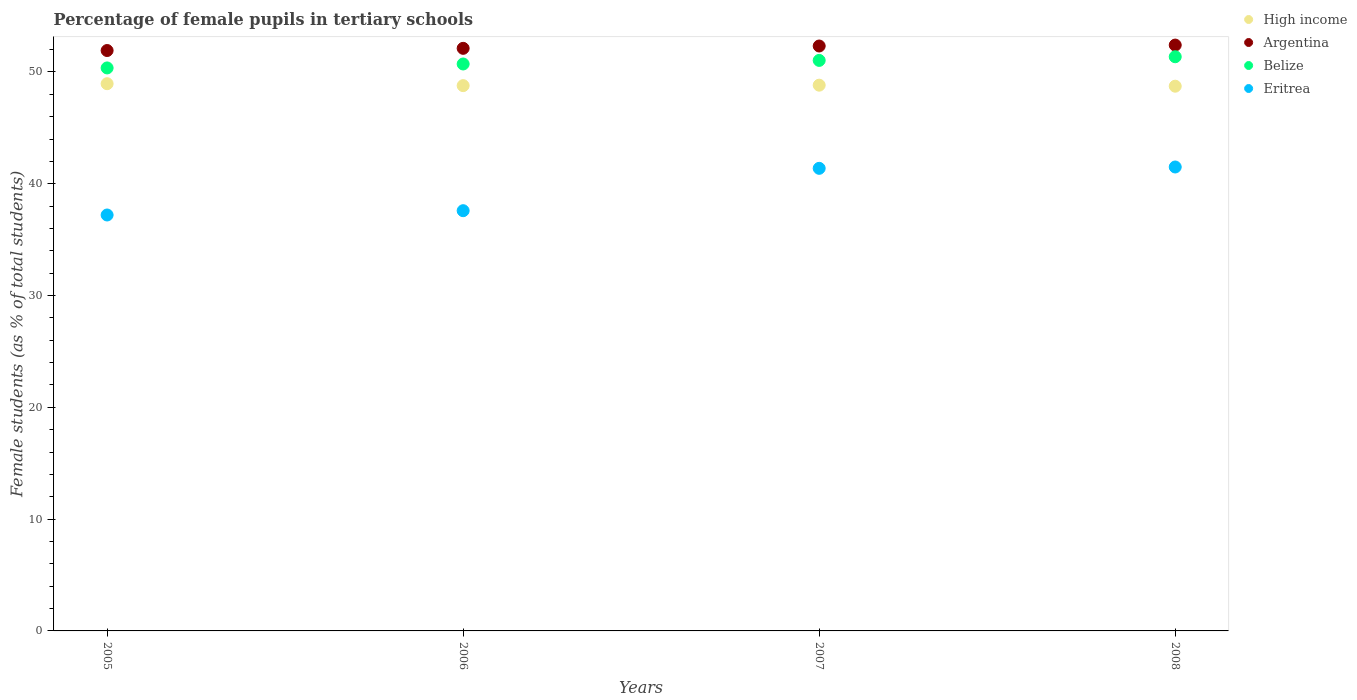How many different coloured dotlines are there?
Provide a short and direct response. 4. What is the percentage of female pupils in tertiary schools in Belize in 2007?
Give a very brief answer. 51.03. Across all years, what is the maximum percentage of female pupils in tertiary schools in High income?
Make the answer very short. 48.95. Across all years, what is the minimum percentage of female pupils in tertiary schools in Eritrea?
Give a very brief answer. 37.2. In which year was the percentage of female pupils in tertiary schools in Argentina maximum?
Ensure brevity in your answer.  2008. What is the total percentage of female pupils in tertiary schools in Eritrea in the graph?
Keep it short and to the point. 157.67. What is the difference between the percentage of female pupils in tertiary schools in Belize in 2005 and that in 2008?
Make the answer very short. -1. What is the difference between the percentage of female pupils in tertiary schools in Eritrea in 2007 and the percentage of female pupils in tertiary schools in High income in 2008?
Your answer should be very brief. -7.35. What is the average percentage of female pupils in tertiary schools in Eritrea per year?
Your answer should be very brief. 39.42. In the year 2007, what is the difference between the percentage of female pupils in tertiary schools in High income and percentage of female pupils in tertiary schools in Eritrea?
Offer a very short reply. 7.44. In how many years, is the percentage of female pupils in tertiary schools in Eritrea greater than 38 %?
Provide a succinct answer. 2. What is the ratio of the percentage of female pupils in tertiary schools in High income in 2005 to that in 2008?
Ensure brevity in your answer.  1. Is the percentage of female pupils in tertiary schools in Argentina in 2007 less than that in 2008?
Your answer should be very brief. Yes. What is the difference between the highest and the second highest percentage of female pupils in tertiary schools in Belize?
Keep it short and to the point. 0.33. What is the difference between the highest and the lowest percentage of female pupils in tertiary schools in Argentina?
Ensure brevity in your answer.  0.49. In how many years, is the percentage of female pupils in tertiary schools in Eritrea greater than the average percentage of female pupils in tertiary schools in Eritrea taken over all years?
Your answer should be very brief. 2. Is it the case that in every year, the sum of the percentage of female pupils in tertiary schools in Argentina and percentage of female pupils in tertiary schools in High income  is greater than the sum of percentage of female pupils in tertiary schools in Belize and percentage of female pupils in tertiary schools in Eritrea?
Give a very brief answer. Yes. Does the percentage of female pupils in tertiary schools in Belize monotonically increase over the years?
Make the answer very short. Yes. Is the percentage of female pupils in tertiary schools in Eritrea strictly greater than the percentage of female pupils in tertiary schools in Belize over the years?
Your answer should be very brief. No. How many years are there in the graph?
Offer a very short reply. 4. Are the values on the major ticks of Y-axis written in scientific E-notation?
Offer a very short reply. No. Where does the legend appear in the graph?
Keep it short and to the point. Top right. How many legend labels are there?
Give a very brief answer. 4. How are the legend labels stacked?
Your answer should be compact. Vertical. What is the title of the graph?
Keep it short and to the point. Percentage of female pupils in tertiary schools. Does "Croatia" appear as one of the legend labels in the graph?
Offer a very short reply. No. What is the label or title of the X-axis?
Your answer should be very brief. Years. What is the label or title of the Y-axis?
Keep it short and to the point. Female students (as % of total students). What is the Female students (as % of total students) in High income in 2005?
Offer a terse response. 48.95. What is the Female students (as % of total students) in Argentina in 2005?
Your answer should be compact. 51.92. What is the Female students (as % of total students) of Belize in 2005?
Offer a very short reply. 50.36. What is the Female students (as % of total students) of Eritrea in 2005?
Offer a terse response. 37.2. What is the Female students (as % of total students) of High income in 2006?
Provide a short and direct response. 48.78. What is the Female students (as % of total students) in Argentina in 2006?
Give a very brief answer. 52.11. What is the Female students (as % of total students) in Belize in 2006?
Ensure brevity in your answer.  50.71. What is the Female students (as % of total students) in Eritrea in 2006?
Provide a succinct answer. 37.59. What is the Female students (as % of total students) of High income in 2007?
Your answer should be very brief. 48.82. What is the Female students (as % of total students) of Argentina in 2007?
Your answer should be very brief. 52.32. What is the Female students (as % of total students) of Belize in 2007?
Your answer should be very brief. 51.03. What is the Female students (as % of total students) of Eritrea in 2007?
Provide a short and direct response. 41.38. What is the Female students (as % of total students) in High income in 2008?
Your answer should be very brief. 48.72. What is the Female students (as % of total students) of Argentina in 2008?
Your answer should be very brief. 52.4. What is the Female students (as % of total students) in Belize in 2008?
Provide a succinct answer. 51.36. What is the Female students (as % of total students) of Eritrea in 2008?
Make the answer very short. 41.5. Across all years, what is the maximum Female students (as % of total students) in High income?
Provide a short and direct response. 48.95. Across all years, what is the maximum Female students (as % of total students) in Argentina?
Give a very brief answer. 52.4. Across all years, what is the maximum Female students (as % of total students) of Belize?
Offer a terse response. 51.36. Across all years, what is the maximum Female students (as % of total students) in Eritrea?
Offer a terse response. 41.5. Across all years, what is the minimum Female students (as % of total students) of High income?
Give a very brief answer. 48.72. Across all years, what is the minimum Female students (as % of total students) of Argentina?
Make the answer very short. 51.92. Across all years, what is the minimum Female students (as % of total students) of Belize?
Your response must be concise. 50.36. Across all years, what is the minimum Female students (as % of total students) of Eritrea?
Provide a short and direct response. 37.2. What is the total Female students (as % of total students) of High income in the graph?
Ensure brevity in your answer.  195.26. What is the total Female students (as % of total students) of Argentina in the graph?
Give a very brief answer. 208.75. What is the total Female students (as % of total students) in Belize in the graph?
Keep it short and to the point. 203.46. What is the total Female students (as % of total students) in Eritrea in the graph?
Make the answer very short. 157.67. What is the difference between the Female students (as % of total students) of High income in 2005 and that in 2006?
Keep it short and to the point. 0.17. What is the difference between the Female students (as % of total students) in Argentina in 2005 and that in 2006?
Offer a terse response. -0.2. What is the difference between the Female students (as % of total students) of Belize in 2005 and that in 2006?
Your response must be concise. -0.35. What is the difference between the Female students (as % of total students) in Eritrea in 2005 and that in 2006?
Offer a terse response. -0.38. What is the difference between the Female students (as % of total students) in High income in 2005 and that in 2007?
Offer a terse response. 0.13. What is the difference between the Female students (as % of total students) of Argentina in 2005 and that in 2007?
Provide a succinct answer. -0.4. What is the difference between the Female students (as % of total students) in Belize in 2005 and that in 2007?
Keep it short and to the point. -0.67. What is the difference between the Female students (as % of total students) in Eritrea in 2005 and that in 2007?
Provide a short and direct response. -4.17. What is the difference between the Female students (as % of total students) in High income in 2005 and that in 2008?
Offer a terse response. 0.22. What is the difference between the Female students (as % of total students) in Argentina in 2005 and that in 2008?
Provide a short and direct response. -0.49. What is the difference between the Female students (as % of total students) of Belize in 2005 and that in 2008?
Keep it short and to the point. -1. What is the difference between the Female students (as % of total students) of Eritrea in 2005 and that in 2008?
Your answer should be compact. -4.29. What is the difference between the Female students (as % of total students) in High income in 2006 and that in 2007?
Give a very brief answer. -0.04. What is the difference between the Female students (as % of total students) in Argentina in 2006 and that in 2007?
Keep it short and to the point. -0.21. What is the difference between the Female students (as % of total students) of Belize in 2006 and that in 2007?
Your answer should be very brief. -0.32. What is the difference between the Female students (as % of total students) of Eritrea in 2006 and that in 2007?
Keep it short and to the point. -3.79. What is the difference between the Female students (as % of total students) of High income in 2006 and that in 2008?
Ensure brevity in your answer.  0.05. What is the difference between the Female students (as % of total students) in Argentina in 2006 and that in 2008?
Keep it short and to the point. -0.29. What is the difference between the Female students (as % of total students) in Belize in 2006 and that in 2008?
Provide a succinct answer. -0.65. What is the difference between the Female students (as % of total students) of Eritrea in 2006 and that in 2008?
Provide a short and direct response. -3.91. What is the difference between the Female students (as % of total students) in High income in 2007 and that in 2008?
Your answer should be compact. 0.09. What is the difference between the Female students (as % of total students) of Argentina in 2007 and that in 2008?
Your answer should be compact. -0.08. What is the difference between the Female students (as % of total students) of Belize in 2007 and that in 2008?
Ensure brevity in your answer.  -0.33. What is the difference between the Female students (as % of total students) of Eritrea in 2007 and that in 2008?
Keep it short and to the point. -0.12. What is the difference between the Female students (as % of total students) in High income in 2005 and the Female students (as % of total students) in Argentina in 2006?
Offer a very short reply. -3.16. What is the difference between the Female students (as % of total students) in High income in 2005 and the Female students (as % of total students) in Belize in 2006?
Keep it short and to the point. -1.76. What is the difference between the Female students (as % of total students) in High income in 2005 and the Female students (as % of total students) in Eritrea in 2006?
Offer a terse response. 11.36. What is the difference between the Female students (as % of total students) in Argentina in 2005 and the Female students (as % of total students) in Belize in 2006?
Provide a short and direct response. 1.2. What is the difference between the Female students (as % of total students) of Argentina in 2005 and the Female students (as % of total students) of Eritrea in 2006?
Offer a very short reply. 14.33. What is the difference between the Female students (as % of total students) of Belize in 2005 and the Female students (as % of total students) of Eritrea in 2006?
Your answer should be very brief. 12.77. What is the difference between the Female students (as % of total students) in High income in 2005 and the Female students (as % of total students) in Argentina in 2007?
Offer a very short reply. -3.37. What is the difference between the Female students (as % of total students) in High income in 2005 and the Female students (as % of total students) in Belize in 2007?
Make the answer very short. -2.08. What is the difference between the Female students (as % of total students) of High income in 2005 and the Female students (as % of total students) of Eritrea in 2007?
Provide a succinct answer. 7.57. What is the difference between the Female students (as % of total students) of Argentina in 2005 and the Female students (as % of total students) of Belize in 2007?
Your response must be concise. 0.88. What is the difference between the Female students (as % of total students) in Argentina in 2005 and the Female students (as % of total students) in Eritrea in 2007?
Give a very brief answer. 10.54. What is the difference between the Female students (as % of total students) of Belize in 2005 and the Female students (as % of total students) of Eritrea in 2007?
Offer a very short reply. 8.98. What is the difference between the Female students (as % of total students) in High income in 2005 and the Female students (as % of total students) in Argentina in 2008?
Offer a very short reply. -3.46. What is the difference between the Female students (as % of total students) in High income in 2005 and the Female students (as % of total students) in Belize in 2008?
Provide a succinct answer. -2.41. What is the difference between the Female students (as % of total students) of High income in 2005 and the Female students (as % of total students) of Eritrea in 2008?
Provide a succinct answer. 7.45. What is the difference between the Female students (as % of total students) of Argentina in 2005 and the Female students (as % of total students) of Belize in 2008?
Offer a very short reply. 0.56. What is the difference between the Female students (as % of total students) of Argentina in 2005 and the Female students (as % of total students) of Eritrea in 2008?
Keep it short and to the point. 10.42. What is the difference between the Female students (as % of total students) in Belize in 2005 and the Female students (as % of total students) in Eritrea in 2008?
Ensure brevity in your answer.  8.86. What is the difference between the Female students (as % of total students) of High income in 2006 and the Female students (as % of total students) of Argentina in 2007?
Ensure brevity in your answer.  -3.54. What is the difference between the Female students (as % of total students) in High income in 2006 and the Female students (as % of total students) in Belize in 2007?
Make the answer very short. -2.26. What is the difference between the Female students (as % of total students) in High income in 2006 and the Female students (as % of total students) in Eritrea in 2007?
Offer a very short reply. 7.4. What is the difference between the Female students (as % of total students) of Argentina in 2006 and the Female students (as % of total students) of Belize in 2007?
Make the answer very short. 1.08. What is the difference between the Female students (as % of total students) in Argentina in 2006 and the Female students (as % of total students) in Eritrea in 2007?
Ensure brevity in your answer.  10.73. What is the difference between the Female students (as % of total students) of Belize in 2006 and the Female students (as % of total students) of Eritrea in 2007?
Offer a terse response. 9.33. What is the difference between the Female students (as % of total students) in High income in 2006 and the Female students (as % of total students) in Argentina in 2008?
Keep it short and to the point. -3.63. What is the difference between the Female students (as % of total students) in High income in 2006 and the Female students (as % of total students) in Belize in 2008?
Your response must be concise. -2.58. What is the difference between the Female students (as % of total students) in High income in 2006 and the Female students (as % of total students) in Eritrea in 2008?
Provide a succinct answer. 7.28. What is the difference between the Female students (as % of total students) in Argentina in 2006 and the Female students (as % of total students) in Belize in 2008?
Make the answer very short. 0.75. What is the difference between the Female students (as % of total students) in Argentina in 2006 and the Female students (as % of total students) in Eritrea in 2008?
Make the answer very short. 10.61. What is the difference between the Female students (as % of total students) of Belize in 2006 and the Female students (as % of total students) of Eritrea in 2008?
Provide a short and direct response. 9.21. What is the difference between the Female students (as % of total students) in High income in 2007 and the Female students (as % of total students) in Argentina in 2008?
Your answer should be compact. -3.59. What is the difference between the Female students (as % of total students) in High income in 2007 and the Female students (as % of total students) in Belize in 2008?
Make the answer very short. -2.54. What is the difference between the Female students (as % of total students) in High income in 2007 and the Female students (as % of total students) in Eritrea in 2008?
Ensure brevity in your answer.  7.32. What is the difference between the Female students (as % of total students) in Argentina in 2007 and the Female students (as % of total students) in Belize in 2008?
Make the answer very short. 0.96. What is the difference between the Female students (as % of total students) of Argentina in 2007 and the Female students (as % of total students) of Eritrea in 2008?
Make the answer very short. 10.82. What is the difference between the Female students (as % of total students) of Belize in 2007 and the Female students (as % of total students) of Eritrea in 2008?
Keep it short and to the point. 9.53. What is the average Female students (as % of total students) of High income per year?
Your response must be concise. 48.82. What is the average Female students (as % of total students) of Argentina per year?
Provide a short and direct response. 52.19. What is the average Female students (as % of total students) of Belize per year?
Offer a very short reply. 50.87. What is the average Female students (as % of total students) of Eritrea per year?
Make the answer very short. 39.42. In the year 2005, what is the difference between the Female students (as % of total students) in High income and Female students (as % of total students) in Argentina?
Give a very brief answer. -2.97. In the year 2005, what is the difference between the Female students (as % of total students) in High income and Female students (as % of total students) in Belize?
Offer a terse response. -1.41. In the year 2005, what is the difference between the Female students (as % of total students) of High income and Female students (as % of total students) of Eritrea?
Make the answer very short. 11.74. In the year 2005, what is the difference between the Female students (as % of total students) of Argentina and Female students (as % of total students) of Belize?
Keep it short and to the point. 1.56. In the year 2005, what is the difference between the Female students (as % of total students) of Argentina and Female students (as % of total students) of Eritrea?
Offer a terse response. 14.71. In the year 2005, what is the difference between the Female students (as % of total students) in Belize and Female students (as % of total students) in Eritrea?
Give a very brief answer. 13.15. In the year 2006, what is the difference between the Female students (as % of total students) of High income and Female students (as % of total students) of Argentina?
Make the answer very short. -3.34. In the year 2006, what is the difference between the Female students (as % of total students) in High income and Female students (as % of total students) in Belize?
Keep it short and to the point. -1.94. In the year 2006, what is the difference between the Female students (as % of total students) of High income and Female students (as % of total students) of Eritrea?
Your response must be concise. 11.19. In the year 2006, what is the difference between the Female students (as % of total students) in Argentina and Female students (as % of total students) in Belize?
Provide a short and direct response. 1.4. In the year 2006, what is the difference between the Female students (as % of total students) of Argentina and Female students (as % of total students) of Eritrea?
Ensure brevity in your answer.  14.52. In the year 2006, what is the difference between the Female students (as % of total students) of Belize and Female students (as % of total students) of Eritrea?
Make the answer very short. 13.12. In the year 2007, what is the difference between the Female students (as % of total students) in High income and Female students (as % of total students) in Argentina?
Your response must be concise. -3.5. In the year 2007, what is the difference between the Female students (as % of total students) of High income and Female students (as % of total students) of Belize?
Keep it short and to the point. -2.22. In the year 2007, what is the difference between the Female students (as % of total students) in High income and Female students (as % of total students) in Eritrea?
Provide a succinct answer. 7.44. In the year 2007, what is the difference between the Female students (as % of total students) of Argentina and Female students (as % of total students) of Belize?
Your answer should be very brief. 1.29. In the year 2007, what is the difference between the Female students (as % of total students) of Argentina and Female students (as % of total students) of Eritrea?
Your answer should be very brief. 10.94. In the year 2007, what is the difference between the Female students (as % of total students) in Belize and Female students (as % of total students) in Eritrea?
Provide a short and direct response. 9.65. In the year 2008, what is the difference between the Female students (as % of total students) of High income and Female students (as % of total students) of Argentina?
Offer a terse response. -3.68. In the year 2008, what is the difference between the Female students (as % of total students) in High income and Female students (as % of total students) in Belize?
Offer a terse response. -2.63. In the year 2008, what is the difference between the Female students (as % of total students) of High income and Female students (as % of total students) of Eritrea?
Provide a short and direct response. 7.23. In the year 2008, what is the difference between the Female students (as % of total students) of Argentina and Female students (as % of total students) of Belize?
Your response must be concise. 1.04. In the year 2008, what is the difference between the Female students (as % of total students) of Argentina and Female students (as % of total students) of Eritrea?
Offer a very short reply. 10.91. In the year 2008, what is the difference between the Female students (as % of total students) in Belize and Female students (as % of total students) in Eritrea?
Your answer should be compact. 9.86. What is the ratio of the Female students (as % of total students) in Belize in 2005 to that in 2006?
Keep it short and to the point. 0.99. What is the ratio of the Female students (as % of total students) in High income in 2005 to that in 2007?
Offer a terse response. 1. What is the ratio of the Female students (as % of total students) of Eritrea in 2005 to that in 2007?
Give a very brief answer. 0.9. What is the ratio of the Female students (as % of total students) in Argentina in 2005 to that in 2008?
Offer a terse response. 0.99. What is the ratio of the Female students (as % of total students) in Belize in 2005 to that in 2008?
Your response must be concise. 0.98. What is the ratio of the Female students (as % of total students) in Eritrea in 2005 to that in 2008?
Offer a terse response. 0.9. What is the ratio of the Female students (as % of total students) in Eritrea in 2006 to that in 2007?
Your answer should be compact. 0.91. What is the ratio of the Female students (as % of total students) of Belize in 2006 to that in 2008?
Your response must be concise. 0.99. What is the ratio of the Female students (as % of total students) of Eritrea in 2006 to that in 2008?
Keep it short and to the point. 0.91. What is the ratio of the Female students (as % of total students) in Argentina in 2007 to that in 2008?
Ensure brevity in your answer.  1. What is the ratio of the Female students (as % of total students) in Belize in 2007 to that in 2008?
Provide a succinct answer. 0.99. What is the difference between the highest and the second highest Female students (as % of total students) in High income?
Keep it short and to the point. 0.13. What is the difference between the highest and the second highest Female students (as % of total students) in Argentina?
Your response must be concise. 0.08. What is the difference between the highest and the second highest Female students (as % of total students) of Belize?
Your response must be concise. 0.33. What is the difference between the highest and the second highest Female students (as % of total students) in Eritrea?
Give a very brief answer. 0.12. What is the difference between the highest and the lowest Female students (as % of total students) of High income?
Keep it short and to the point. 0.22. What is the difference between the highest and the lowest Female students (as % of total students) of Argentina?
Provide a short and direct response. 0.49. What is the difference between the highest and the lowest Female students (as % of total students) in Eritrea?
Your answer should be compact. 4.29. 